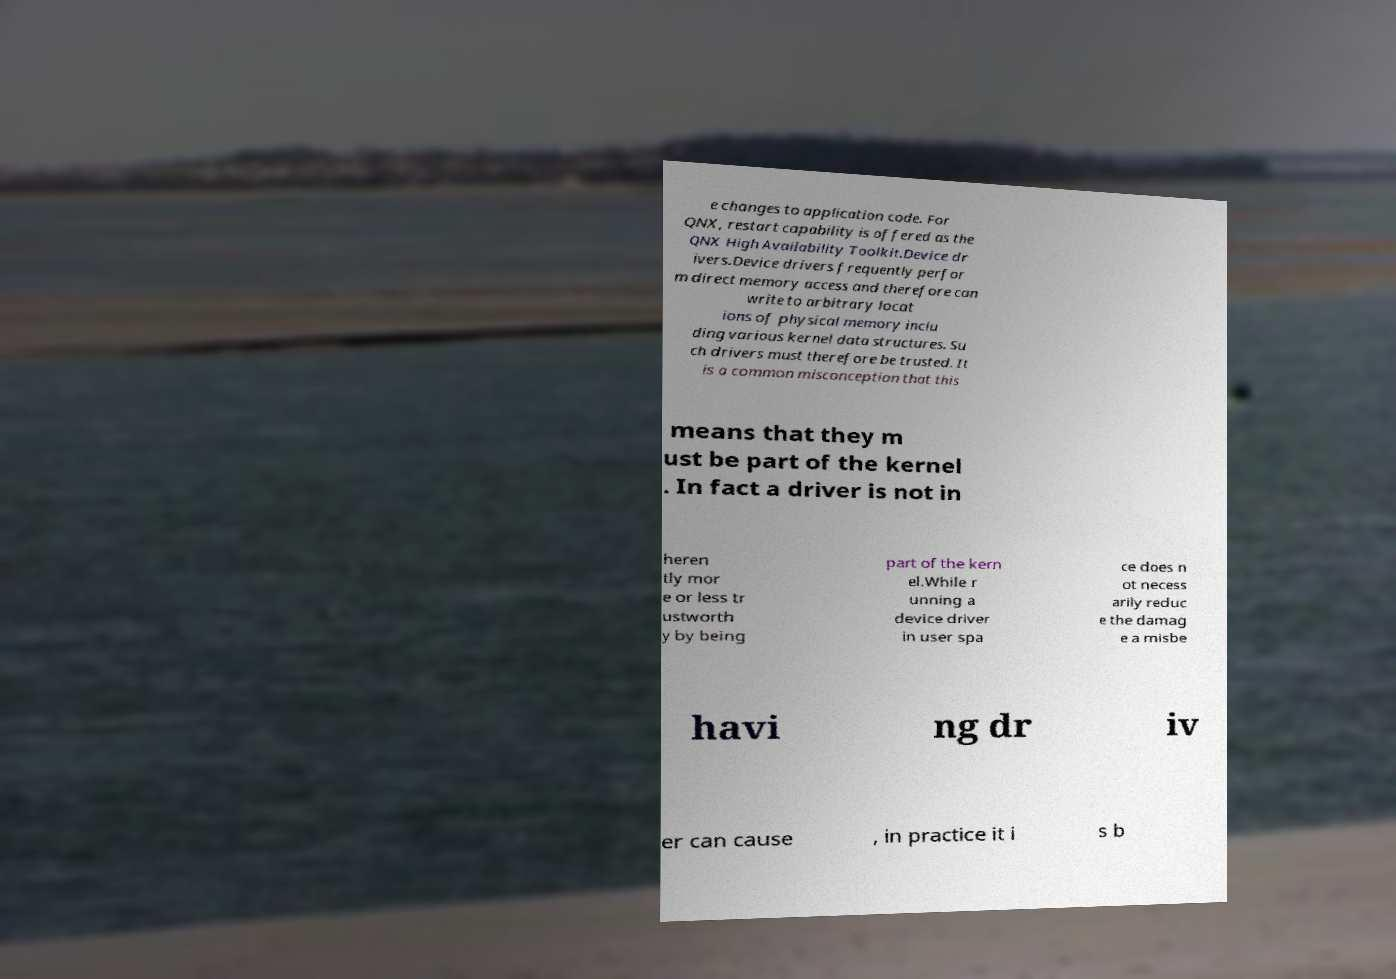I need the written content from this picture converted into text. Can you do that? e changes to application code. For QNX, restart capability is offered as the QNX High Availability Toolkit.Device dr ivers.Device drivers frequently perfor m direct memory access and therefore can write to arbitrary locat ions of physical memory inclu ding various kernel data structures. Su ch drivers must therefore be trusted. It is a common misconception that this means that they m ust be part of the kernel . In fact a driver is not in heren tly mor e or less tr ustworth y by being part of the kern el.While r unning a device driver in user spa ce does n ot necess arily reduc e the damag e a misbe havi ng dr iv er can cause , in practice it i s b 